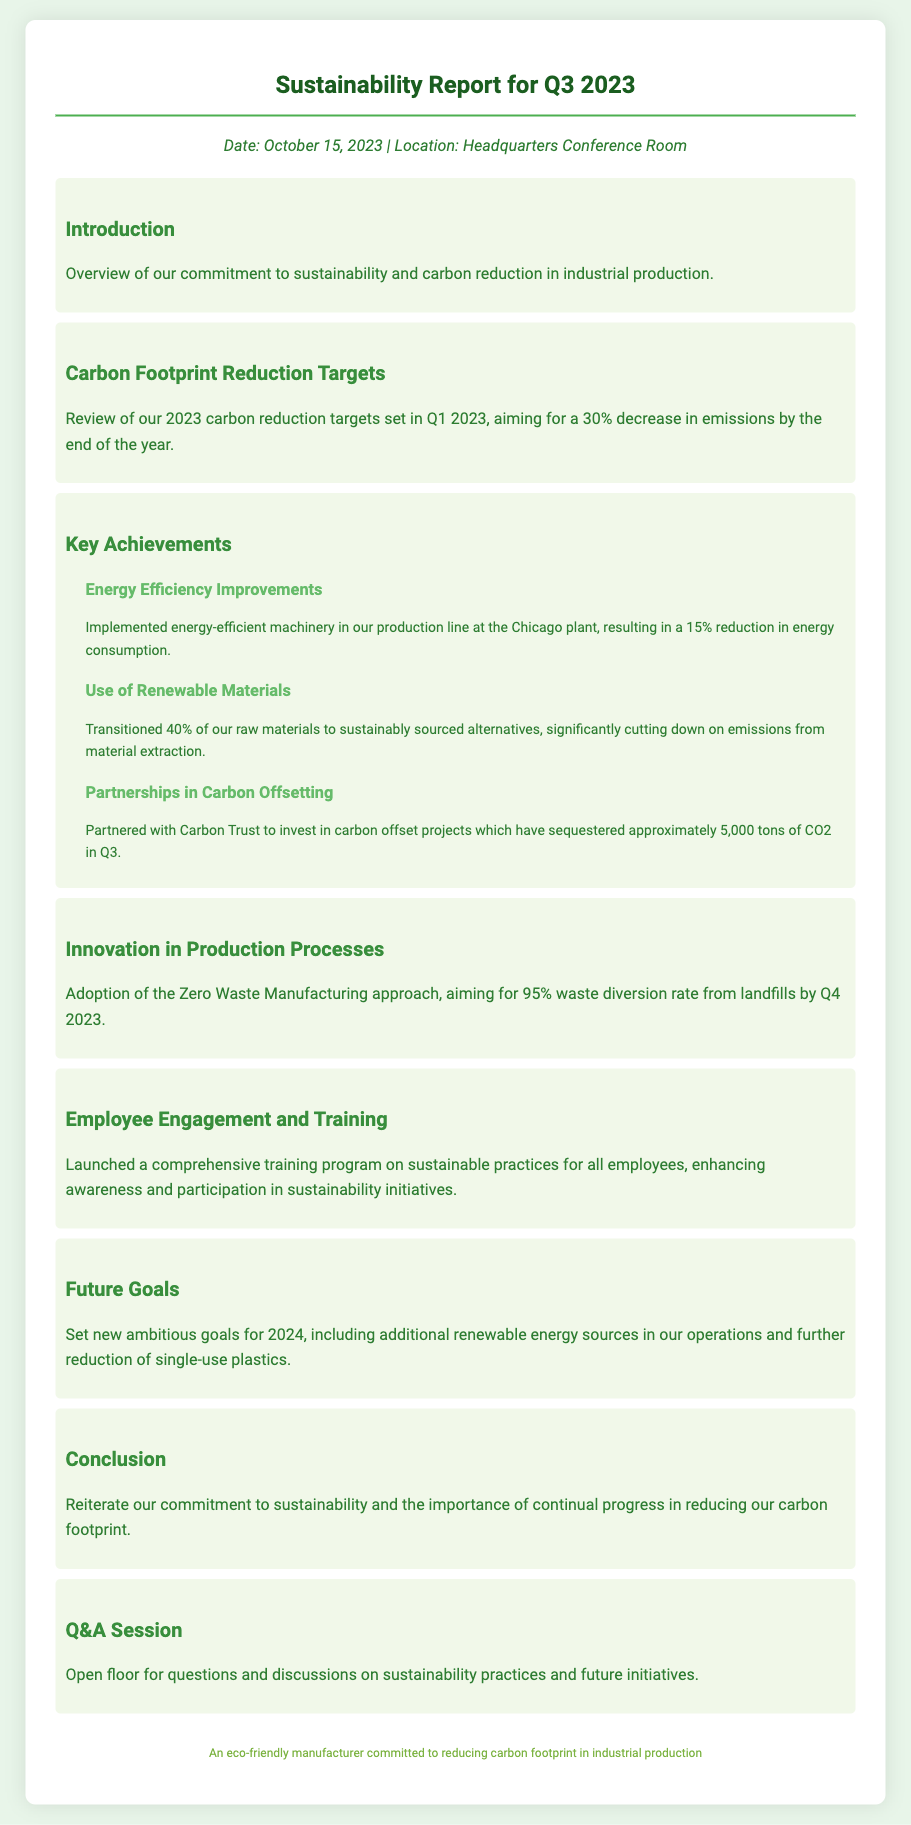What is the date of the report? The date of the report is explicitly mentioned in the header information section.
Answer: October 15, 2023 What was the carbon reduction target for 2023? The carbon reduction target is clearly stated as a percentage aiming for a specific reduction by the end of the year.
Answer: 30% How much CO2 has been sequestered in Q3? The amount of carbon that has been sequestered through partnerships is stated in the section on carbon offsetting.
Answer: 5,000 tons What is the goal for waste diversion by Q4 2023? The target for waste diversion is mentioned in relation to the Zero Waste Manufacturing approach.
Answer: 95% What percentage of raw materials has transitioned to sustainable sources? The document provides a specific percentage regarding the transition of raw materials in the key achievements section.
Answer: 40% Why is the training program important? The purpose of the training program is implied through its enhancement of awareness and participation among employees.
Answer: Enhancing awareness What approach has been adopted for production processes? The production process approach is explicitly stated under innovation in production processes.
Answer: Zero Waste Manufacturing Which organization did the company partner with for carbon offset projects? The organization involved in the carbon offset projects is listed in the partnerships section.
Answer: Carbon Trust What is one of the future goals for 2024 mentioned in the report? Future goals are discussed in a dedicated section, specifying aims for the next year.
Answer: Additional renewable energy sources 